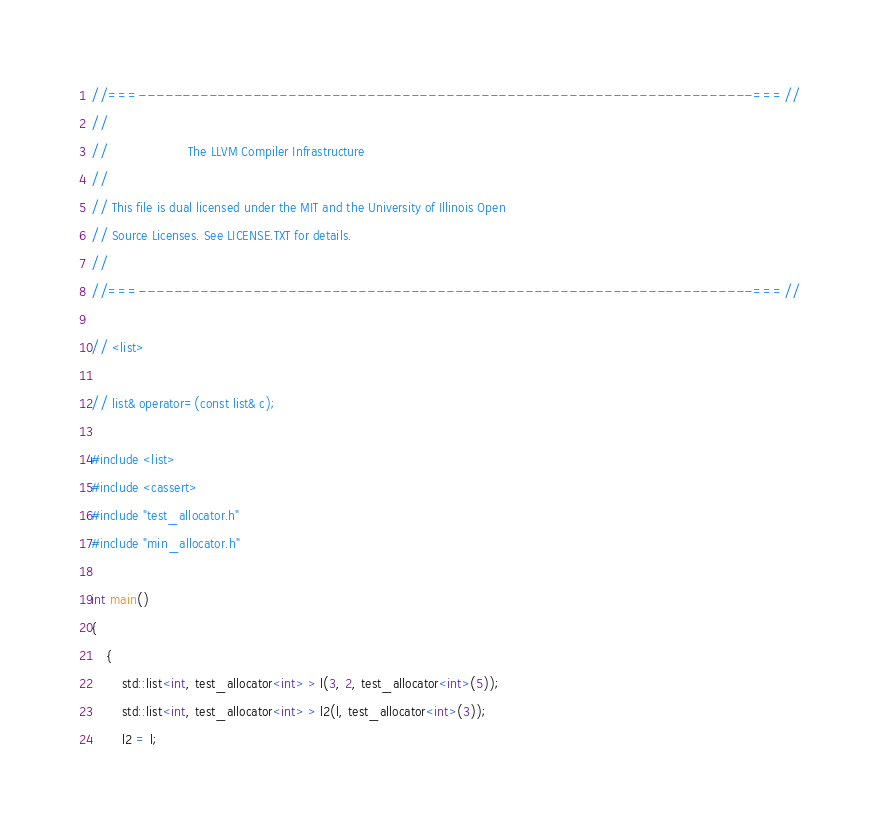Convert code to text. <code><loc_0><loc_0><loc_500><loc_500><_C++_>//===----------------------------------------------------------------------===//
//
//                     The LLVM Compiler Infrastructure
//
// This file is dual licensed under the MIT and the University of Illinois Open
// Source Licenses. See LICENSE.TXT for details.
//
//===----------------------------------------------------------------------===//

// <list>

// list& operator=(const list& c);

#include <list>
#include <cassert>
#include "test_allocator.h"
#include "min_allocator.h"

int main()
{
    {
        std::list<int, test_allocator<int> > l(3, 2, test_allocator<int>(5));
        std::list<int, test_allocator<int> > l2(l, test_allocator<int>(3));
        l2 = l;</code> 